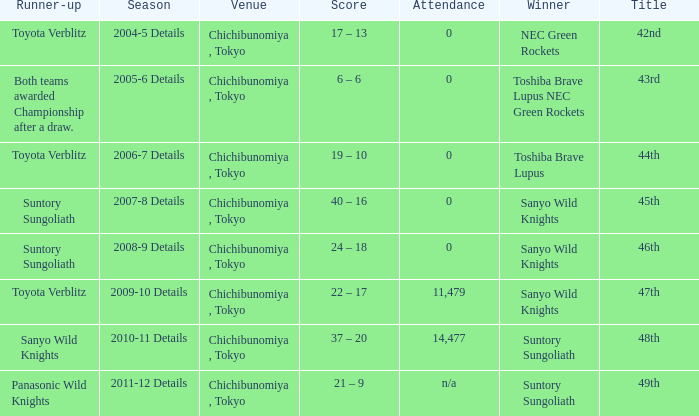What is the Score when the winner was sanyo wild knights, and a Runner-up of suntory sungoliath? 40 – 16, 24 – 18. 